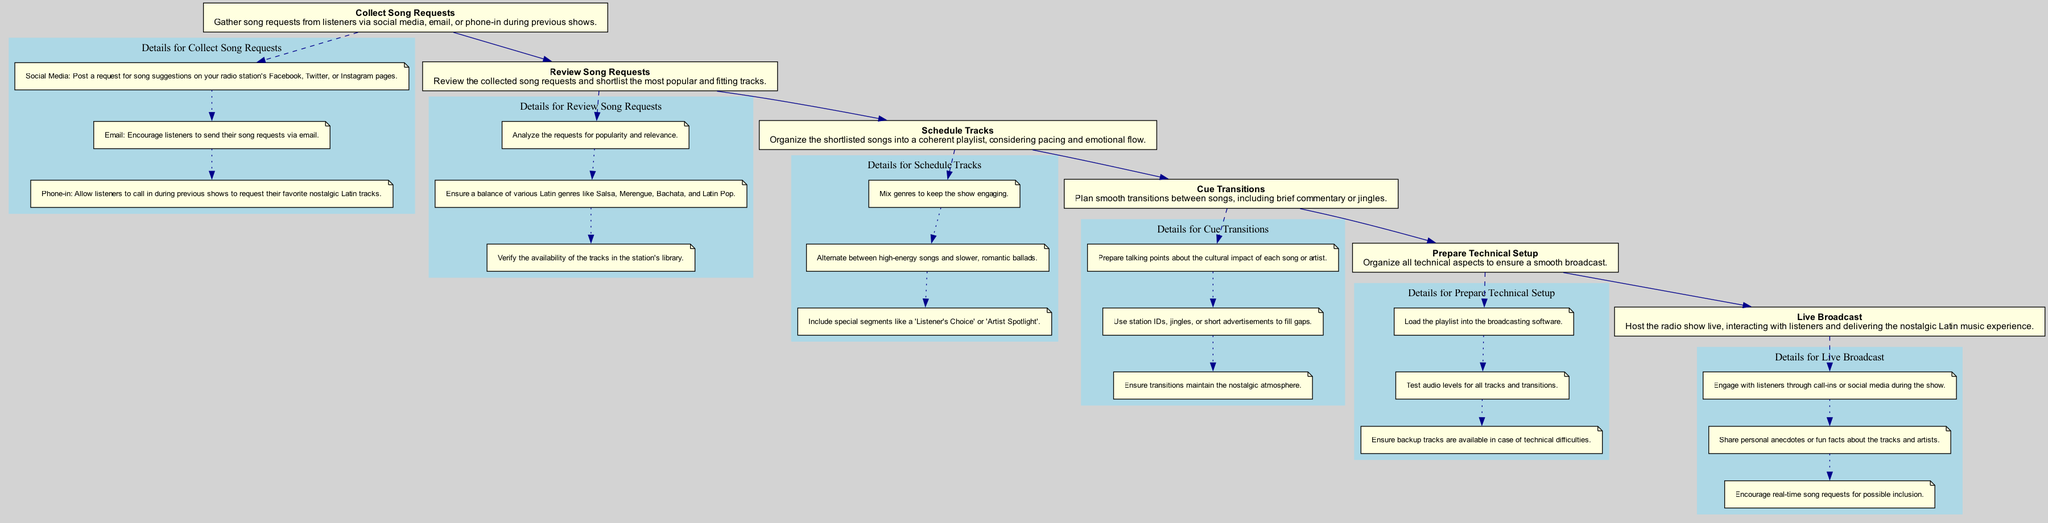What is the first step in preparing the radio show playlist? The first step in the flowchart is "Collect Song Requests". This node appears at the top of the diagram and indicates the initial action required for the process.
Answer: Collect Song Requests How many main elements are in the diagram? Counting the nodes for each main step in the process, there are six main elements represented in the diagram.
Answer: 6 Which step follows "Review Song Requests"? From the flow of the diagram, the step that directly follows "Review Song Requests" is "Schedule Tracks", indicating the next action in the sequence.
Answer: Schedule Tracks What are the two methods for gathering song requests? The diagram lists three methods, but the two requested are "Social Media" and "Email", which are both mentioned under the detailing of the "Collect Song Requests" node.
Answer: Social Media, Email What is included in the details for "Cue Transitions"? The details for "Cue Transitions" include preparing talking points about the cultural impact of songs, using jingles, and ensuring transitions maintain the nostalgic atmosphere, which are indicated under that node in the diagram.
Answer: Prepare talking points, use station IDs, ensure nostalgic atmosphere Which step includes interacting with listeners during the show? The final node labeled "Live Broadcast" contains details about engaging with listeners, indicating this is where interaction occurs during the live show.
Answer: Live Broadcast 